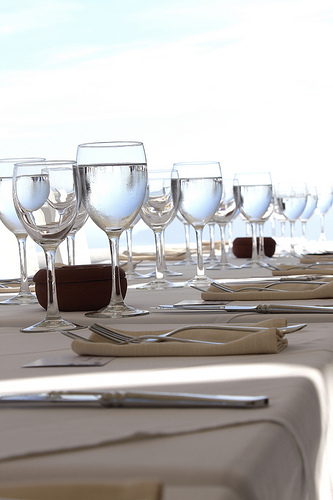<image>
Can you confirm if the water is in the glass? No. The water is not contained within the glass. These objects have a different spatial relationship. 